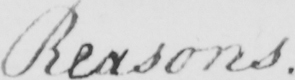What text is written in this handwritten line? Reasons . 